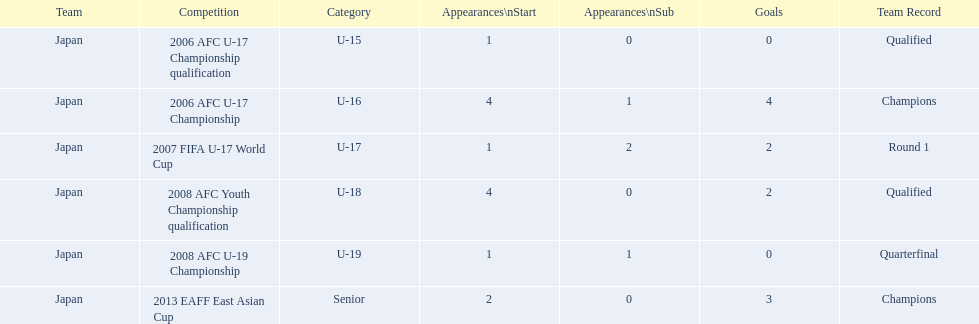Which events has yoichiro kakitani competed in? 2006 AFC U-17 Championship qualification, 2006 AFC U-17 Championship, 2007 FIFA U-17 World Cup, 2008 AFC Youth Championship qualification, 2008 AFC U-19 Championship, 2013 EAFF East Asian Cup. How many times did he start in each of these events? 1, 4, 1, 4, 1, 2. How many goals did he manage to score during those events? 0, 4, 2, 2, 0, 3. In which event did yoichiro achieve his highest number of starts and goals? 2006 AFC U-17 Championship. 